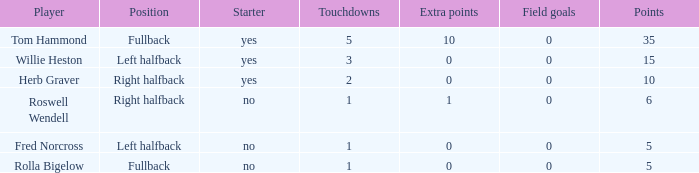For right halfback roswell wendell, what was the count of extra points scored? 1.0. 